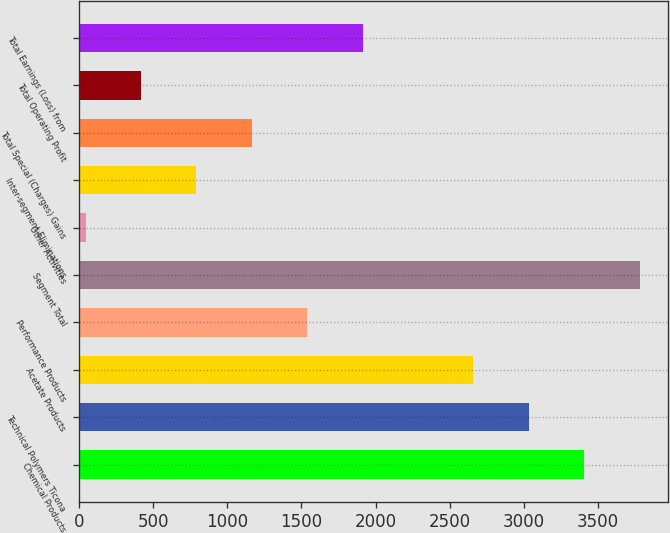Convert chart. <chart><loc_0><loc_0><loc_500><loc_500><bar_chart><fcel>Chemical Products<fcel>Technical Polymers Ticona<fcel>Acetate Products<fcel>Performance Products<fcel>Segment Total<fcel>Other Activities<fcel>Inter-segment Eliminations<fcel>Total Special (Charges) Gains<fcel>Total Operating Profit<fcel>Total Earnings (Loss) from<nl><fcel>3407.4<fcel>3033.8<fcel>2660.2<fcel>1539.4<fcel>3781<fcel>45<fcel>792.2<fcel>1165.8<fcel>418.6<fcel>1913<nl></chart> 